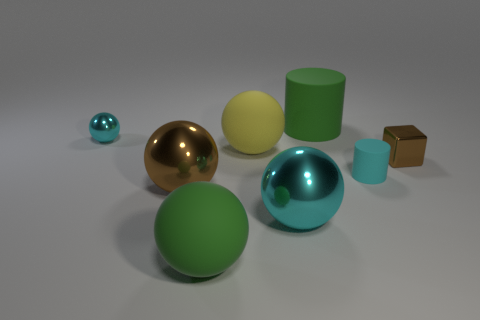Subtract all cyan balls. How many were subtracted if there are1cyan balls left? 1 Add 2 green matte things. How many objects exist? 10 Subtract all large green spheres. How many spheres are left? 4 Subtract all green spheres. How many spheres are left? 4 Subtract all purple cylinders. How many cyan spheres are left? 2 Subtract 2 spheres. How many spheres are left? 3 Subtract all blue cylinders. Subtract all green blocks. How many cylinders are left? 2 Subtract all small purple rubber cylinders. Subtract all yellow objects. How many objects are left? 7 Add 5 metallic spheres. How many metallic spheres are left? 8 Add 7 large gray metallic things. How many large gray metallic things exist? 7 